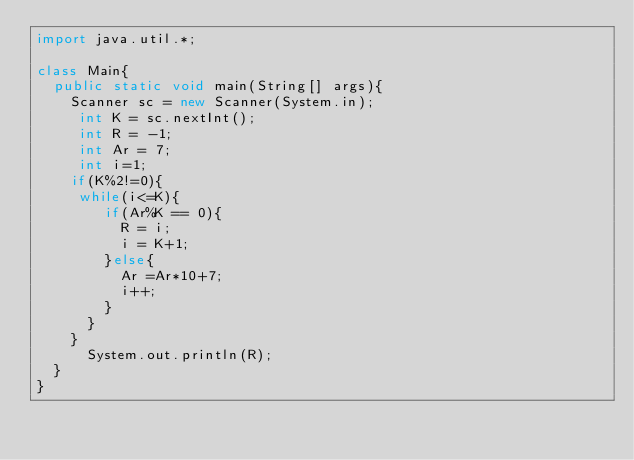Convert code to text. <code><loc_0><loc_0><loc_500><loc_500><_Java_>import java.util.*;
 
class Main{
  public static void main(String[] args){
  	Scanner sc = new Scanner(System.in);
 	 int K = sc.nextInt();
 	 int R = -1;
	 int Ar = 7;
     int i=1;
    if(K%2!=0){
	 while(i<=K){
   	 	if(Ar%K == 0){
    	  R = i;
          i = K+1;
        }else{
    	  Ar =Ar*10+7;
          i++;
    	}
	  }
    }
  	  System.out.println(R);
  }
}</code> 